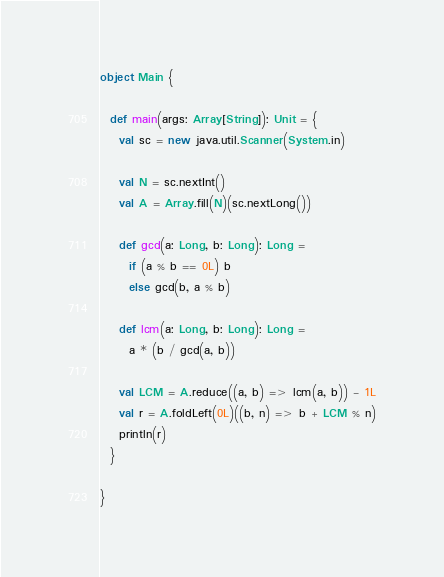Convert code to text. <code><loc_0><loc_0><loc_500><loc_500><_Scala_>object Main {

  def main(args: Array[String]): Unit = {
    val sc = new java.util.Scanner(System.in)

    val N = sc.nextInt()
    val A = Array.fill(N)(sc.nextLong())

    def gcd(a: Long, b: Long): Long =
      if (a % b == 0L) b
      else gcd(b, a % b)

    def lcm(a: Long, b: Long): Long =
      a * (b / gcd(a, b))

    val LCM = A.reduce((a, b) => lcm(a, b)) - 1L
    val r = A.foldLeft(0L)((b, n) => b + LCM % n)
    println(r)
  }

}
</code> 